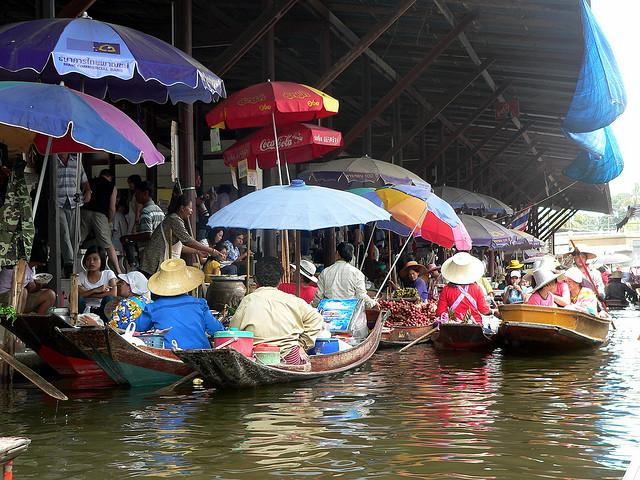What is the woman with a big blue umbrella doing? Please explain your reasoning. selling stuff. It's hard to tell from the image, but this appears to be the case. 